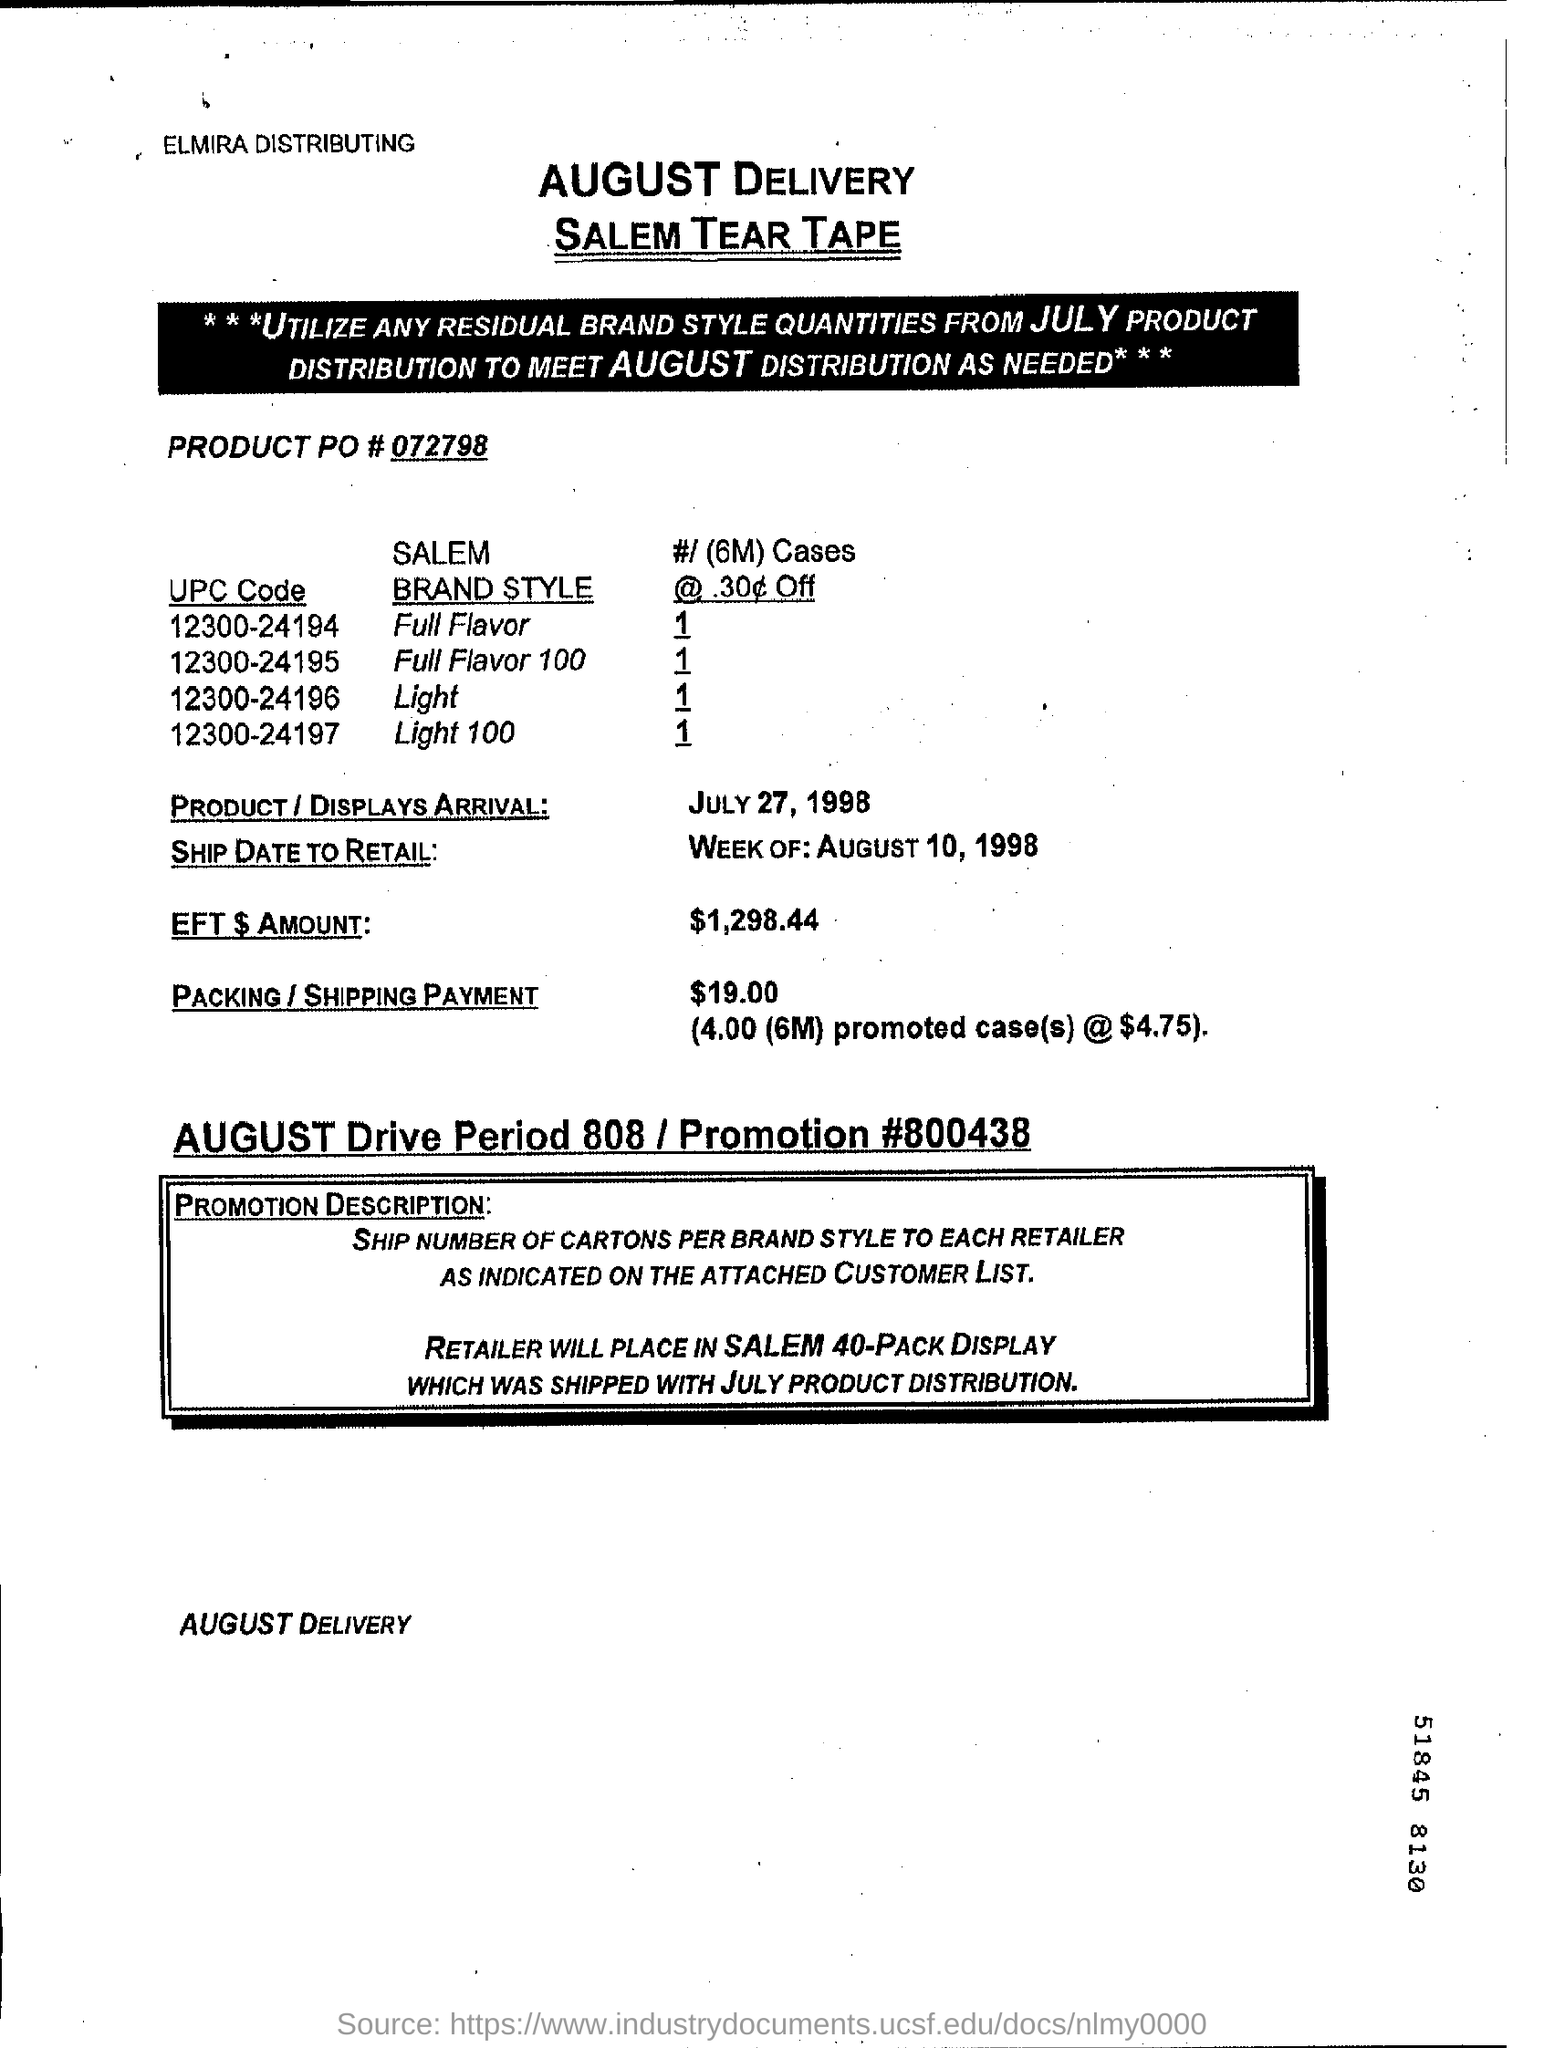List a handful of essential elements in this visual. The shipping and packing charges total $19.00. The product PO number is 072798. The product arrival date is July 27, 1998. The ship date to retail for the week of August 10, 1998 is [object] . 